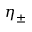<formula> <loc_0><loc_0><loc_500><loc_500>\eta _ { \pm }</formula> 